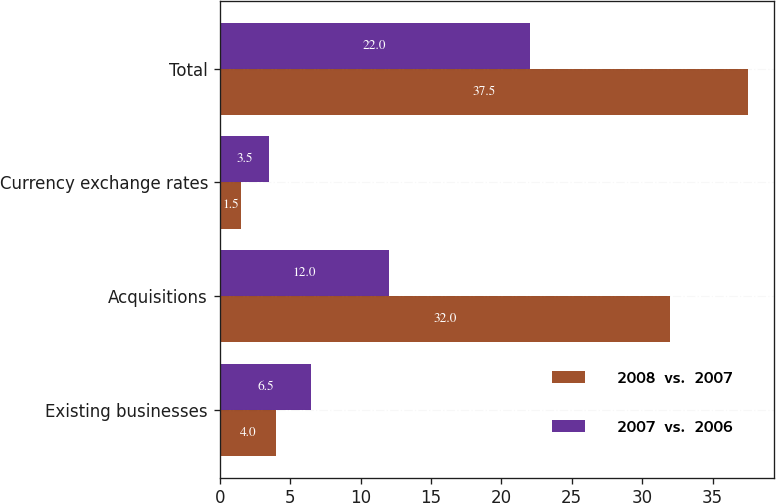<chart> <loc_0><loc_0><loc_500><loc_500><stacked_bar_chart><ecel><fcel>Existing businesses<fcel>Acquisitions<fcel>Currency exchange rates<fcel>Total<nl><fcel>2008  vs.  2007<fcel>4<fcel>32<fcel>1.5<fcel>37.5<nl><fcel>2007  vs.  2006<fcel>6.5<fcel>12<fcel>3.5<fcel>22<nl></chart> 